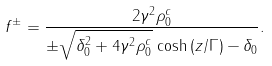Convert formula to latex. <formula><loc_0><loc_0><loc_500><loc_500>f ^ { \pm } = \frac { 2 \gamma ^ { 2 } \rho ^ { c } _ { 0 } } { \pm \sqrt { \delta _ { 0 } ^ { 2 } + 4 \gamma ^ { 2 } \rho ^ { c } _ { 0 } } \, \cosh \, ( z / \Gamma ) - \delta _ { 0 } } .</formula> 